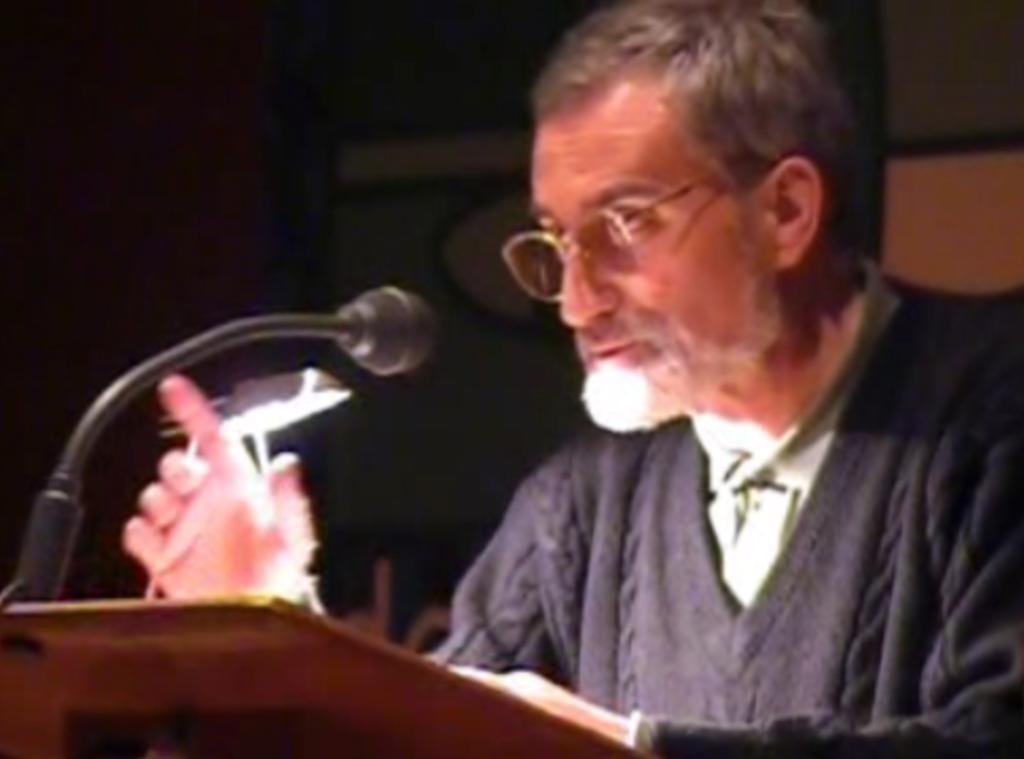Could you give a brief overview of what you see in this image? In this image there is a person standing and speaking, there is a light, there is a microphone, the background of the person is dark. 